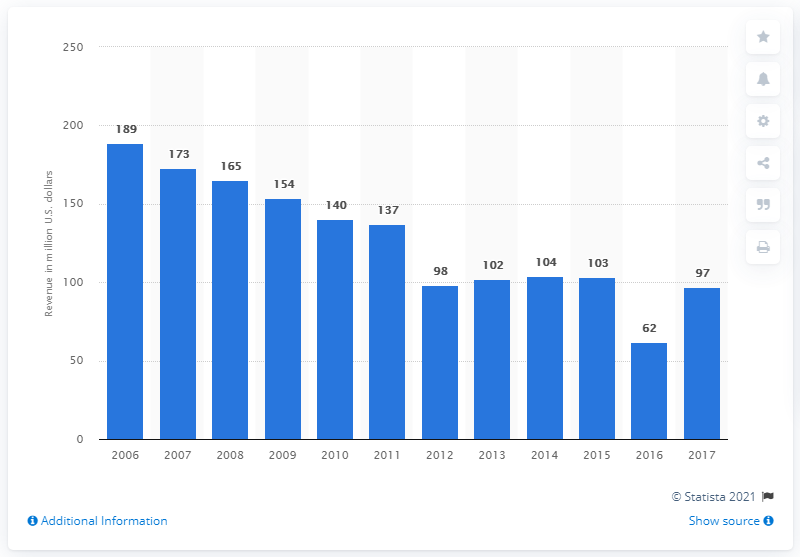Give some essential details in this illustration. Roush Fenway Racing generated revenue of $137 million in 2011. 